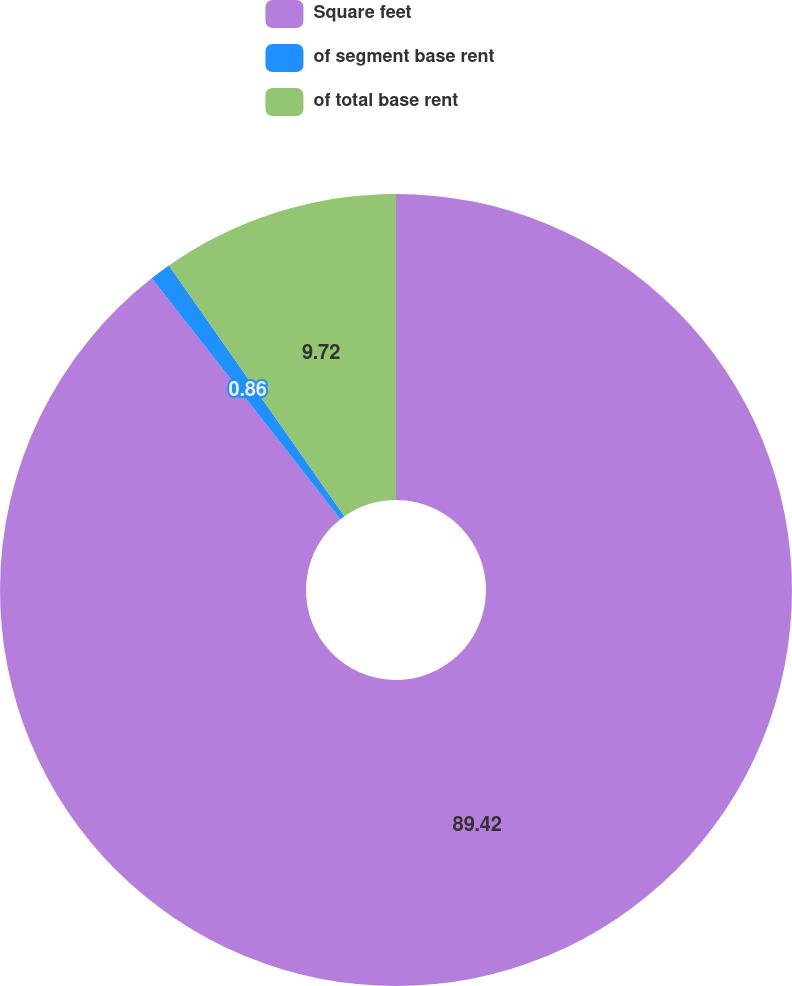<chart> <loc_0><loc_0><loc_500><loc_500><pie_chart><fcel>Square feet<fcel>of segment base rent<fcel>of total base rent<nl><fcel>89.42%<fcel>0.86%<fcel>9.72%<nl></chart> 